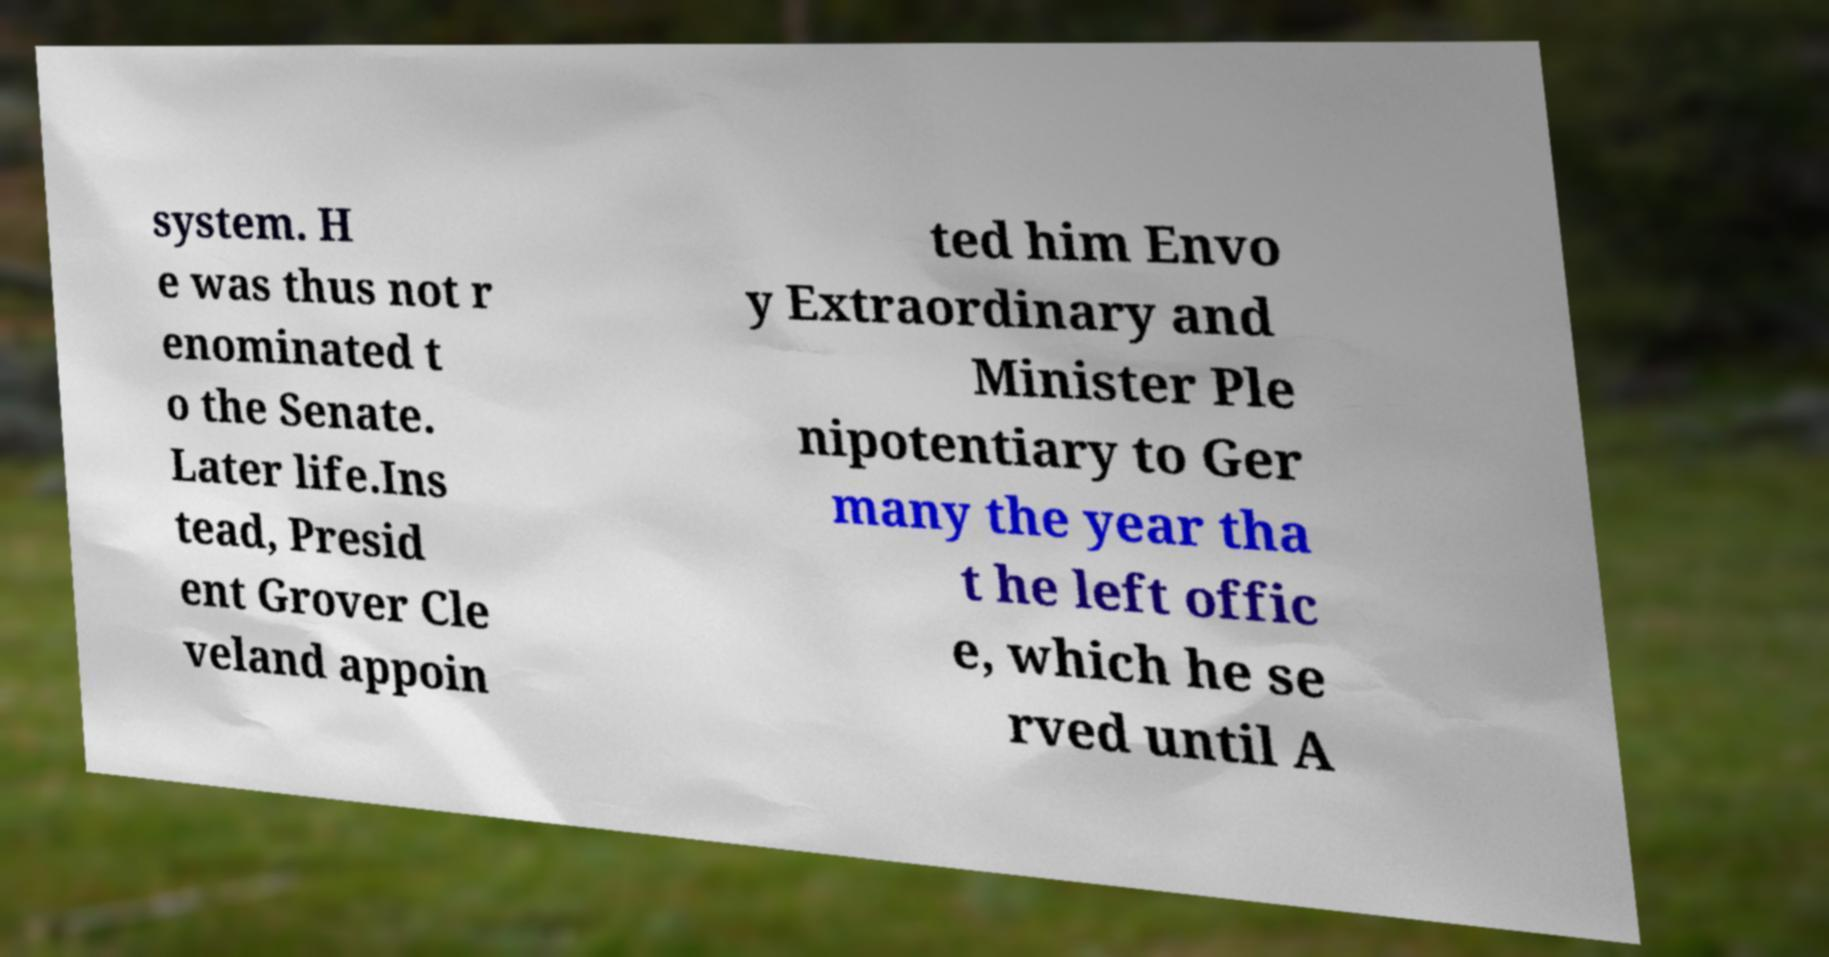Please read and relay the text visible in this image. What does it say? system. H e was thus not r enominated t o the Senate. Later life.Ins tead, Presid ent Grover Cle veland appoin ted him Envo y Extraordinary and Minister Ple nipotentiary to Ger many the year tha t he left offic e, which he se rved until A 